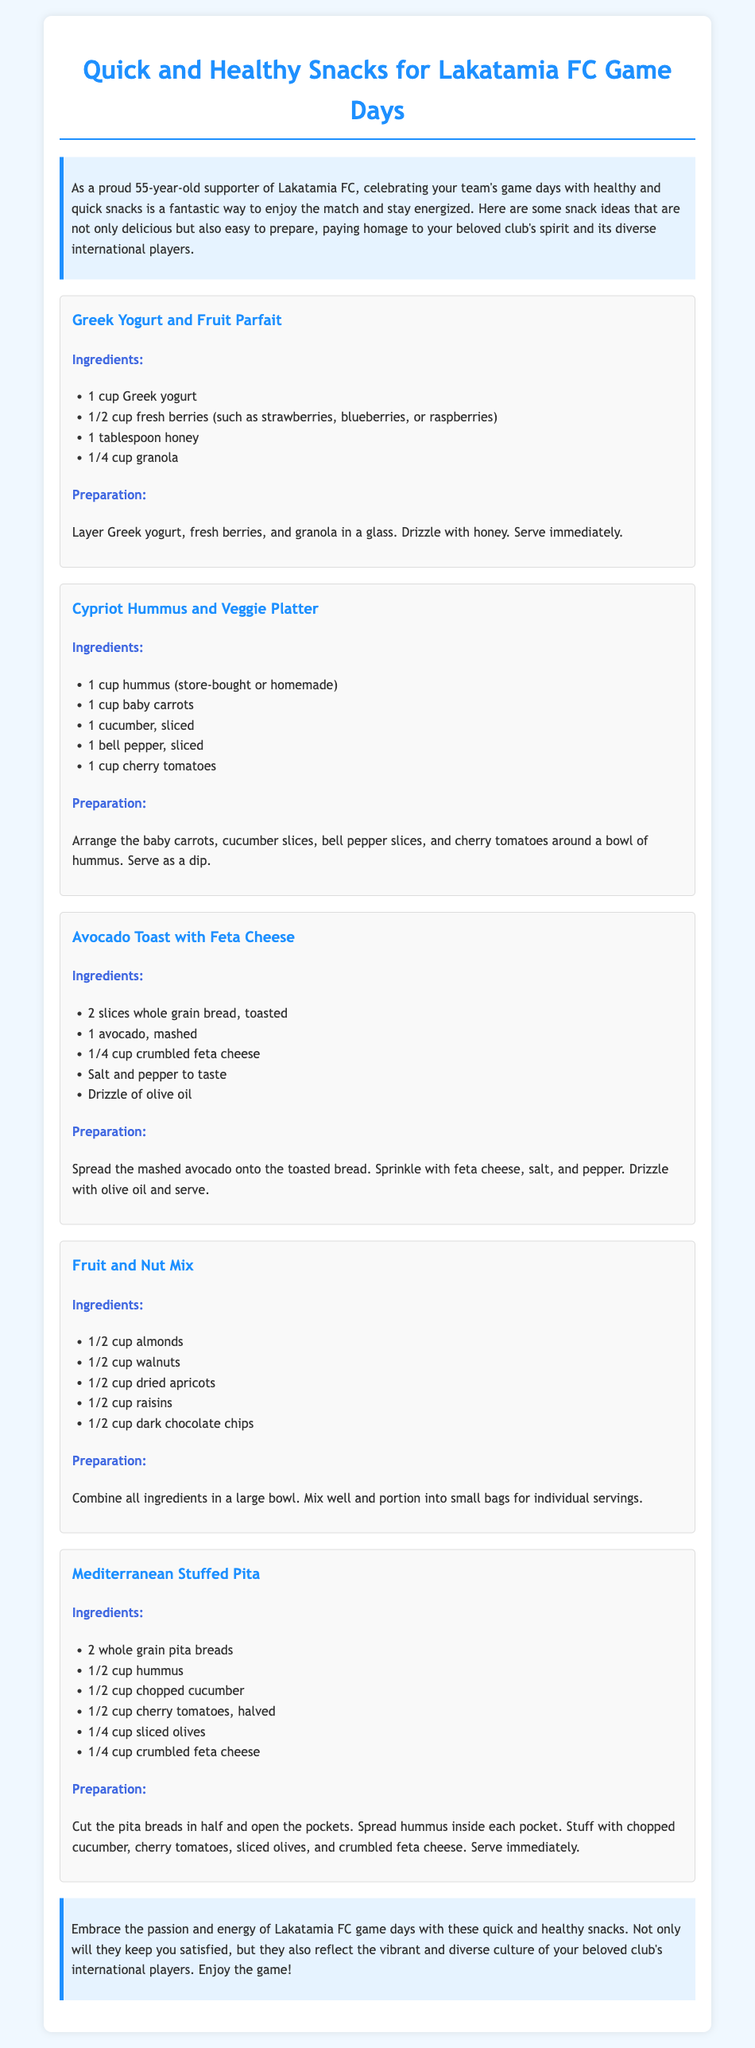What is the first snack mentioned? The first snack mentioned in the document is titled "Greek Yogurt and Fruit Parfait."
Answer: Greek Yogurt and Fruit Parfait How many ingredients does the Avocado Toast with Feta Cheese require? The Avocado Toast with Feta Cheese requires five ingredients as listed in the document.
Answer: 5 What ingredient is used in both the Cypriot Hummus and Veggie Platter and the Mediterranean Stuffed Pita? The common ingredient used in both snacks is hummus.
Answer: Hummus What is the primary base of the Fruit and Nut Mix? The primary base of the Fruit and Nut Mix comprises a combination of nuts and dried fruits.
Answer: Nuts and dried fruits How many pita breads are needed for the Mediterranean Stuffed Pita? According to the document, two whole grain pita breads are needed.
Answer: 2 What type of cheese is used in the Avocado Toast? The type of cheese mentioned for use in the Avocado Toast is feta cheese.
Answer: Feta cheese What is the main purpose of the document? The main purpose of the document is to provide quick and healthy snack ideas for game days.
Answer: Quick and healthy snack ideas for game days How does the document suggest serving the snacks? The document suggests serving the snacks as easy-to-eat dips and spreads during game days.
Answer: Dips and spreads during game days 